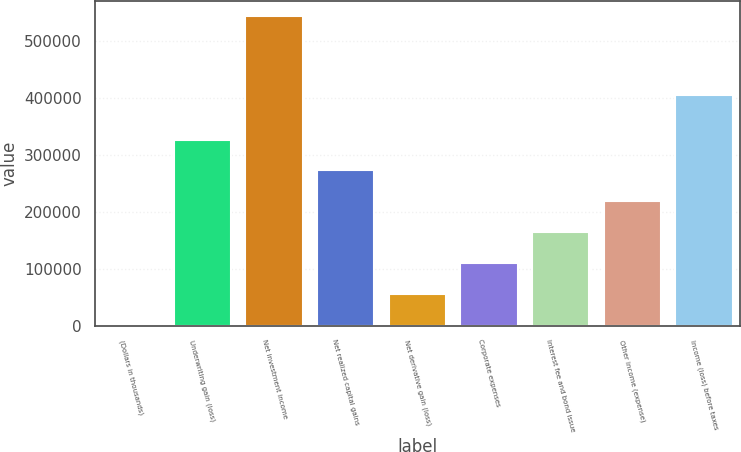Convert chart to OTSL. <chart><loc_0><loc_0><loc_500><loc_500><bar_chart><fcel>(Dollars in thousands)<fcel>Underwriting gain (loss)<fcel>Net investment income<fcel>Net realized capital gains<fcel>Net derivative gain (loss)<fcel>Corporate expenses<fcel>Interest fee and bond issue<fcel>Other income (expense)<fcel>Income (loss) before taxes<nl><fcel>2017<fcel>326546<fcel>542898<fcel>272458<fcel>56105.1<fcel>110193<fcel>164281<fcel>218369<fcel>405184<nl></chart> 